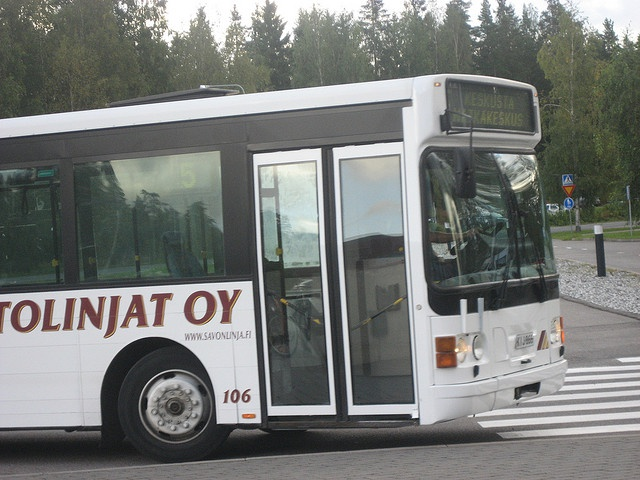Describe the objects in this image and their specific colors. I can see bus in gray, lightgray, black, and darkgray tones and people in gray and black tones in this image. 